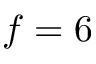<formula> <loc_0><loc_0><loc_500><loc_500>f = 6</formula> 